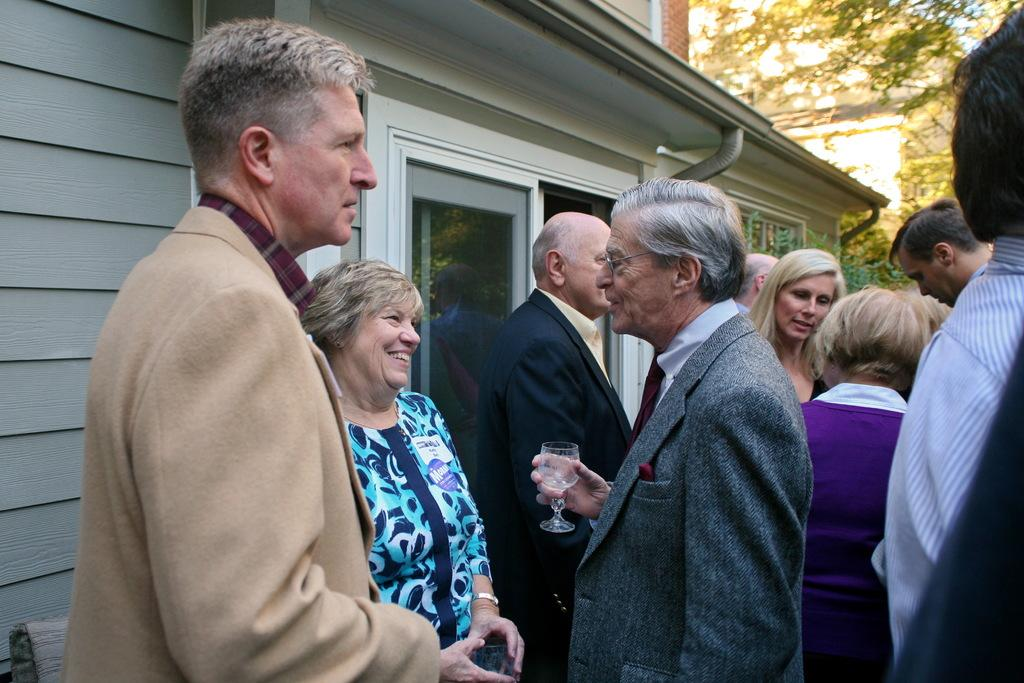What is happening in the image? There are people standing in the image. What is the person in the image holding? A person is holding a glass in his hand. Can you describe the woman in the image? There is a woman in front of the person holding the glass. What can be seen in the distance in the image? There are buildings and trees in the background of the image. What type of orange can be seen on the pancake in the image? There is no orange or pancake present in the image. Can you tell me how many cows are grazing on the farm in the image? There is no farm or cows present in the image. 